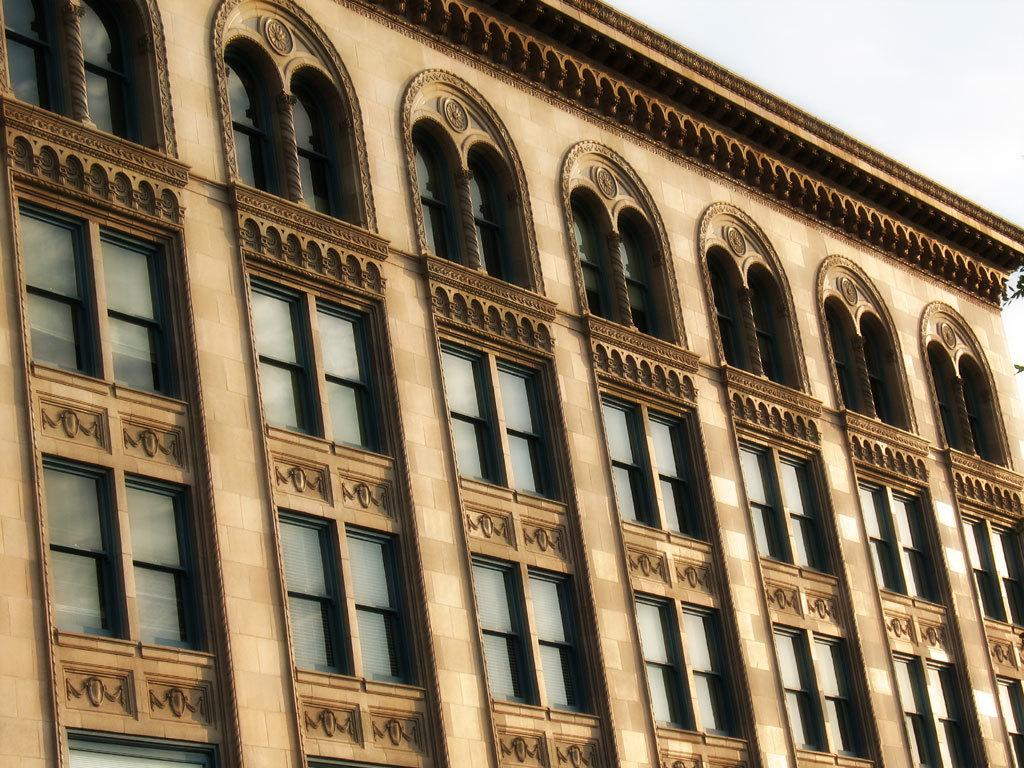What is the main subject of the image? The main subject of the image is a huge building. Can you describe the color of the building? The building is cream and brown in color. What feature can be seen on the building? There are windows on the building. What can be seen in the background of the image? The sky is visible in the background of the image. What type of business is being discussed by the governor in the image? There is no indication of a business or a governor in the image; it only features a huge building with windows and a visible sky in the background. 